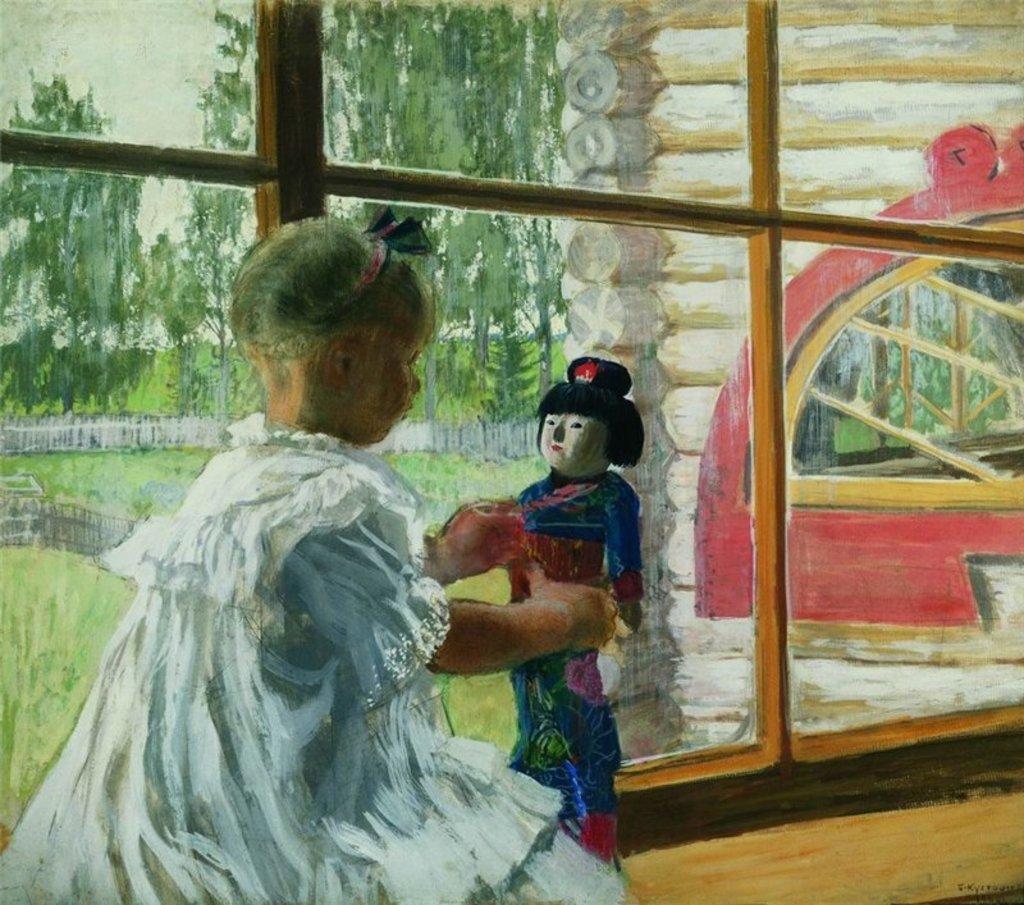Describe this image in one or two sentences. In this image, we can see the painting of a person holding an object. We can see the wall and some windows. We can also see some grass and trees. 